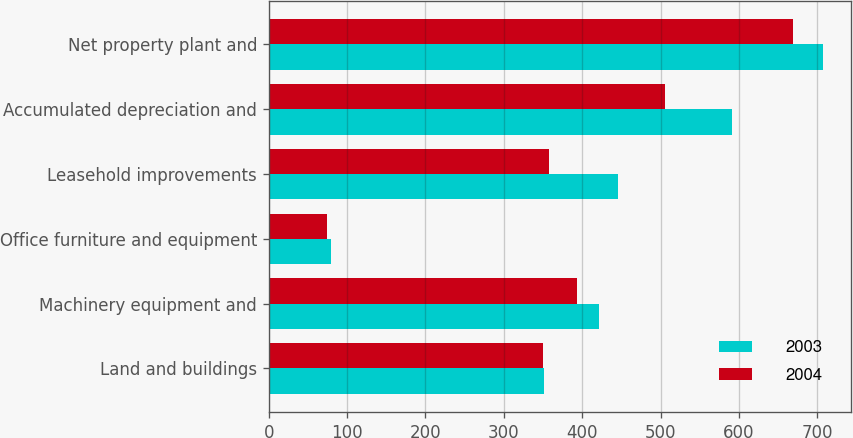<chart> <loc_0><loc_0><loc_500><loc_500><stacked_bar_chart><ecel><fcel>Land and buildings<fcel>Machinery equipment and<fcel>Office furniture and equipment<fcel>Leasehold improvements<fcel>Accumulated depreciation and<fcel>Net property plant and<nl><fcel>2003<fcel>351<fcel>422<fcel>79<fcel>446<fcel>591<fcel>707<nl><fcel>2004<fcel>350<fcel>393<fcel>74<fcel>357<fcel>505<fcel>669<nl></chart> 